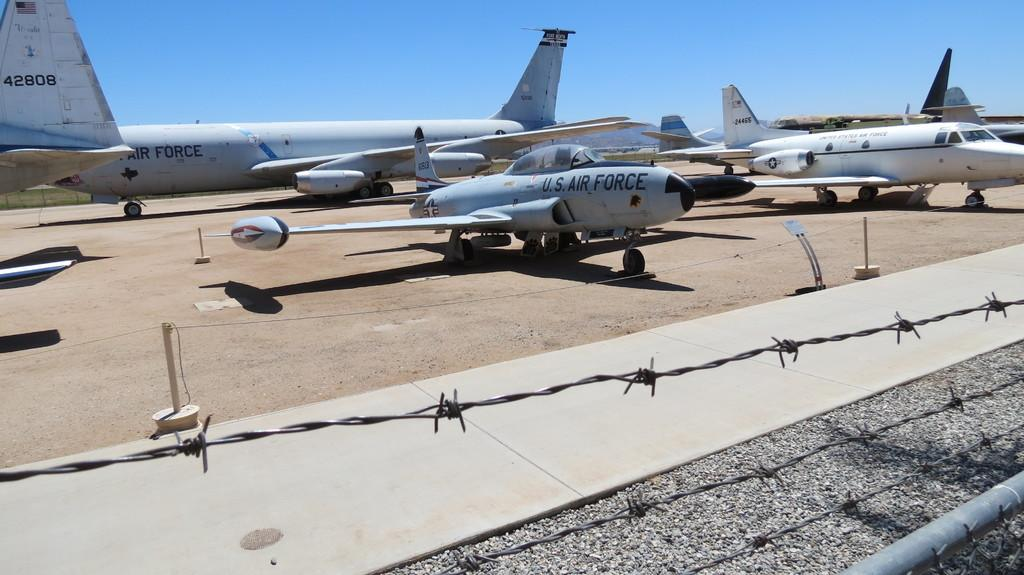<image>
Create a compact narrative representing the image presented. US Air Force plans are arranged in a lot. 